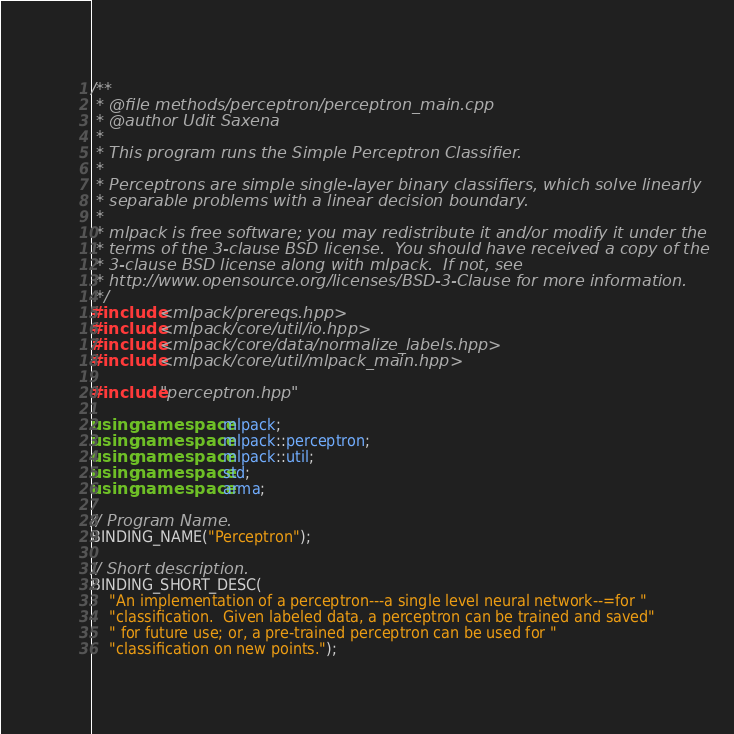Convert code to text. <code><loc_0><loc_0><loc_500><loc_500><_C++_>/**
 * @file methods/perceptron/perceptron_main.cpp
 * @author Udit Saxena
 *
 * This program runs the Simple Perceptron Classifier.
 *
 * Perceptrons are simple single-layer binary classifiers, which solve linearly
 * separable problems with a linear decision boundary.
 *
 * mlpack is free software; you may redistribute it and/or modify it under the
 * terms of the 3-clause BSD license.  You should have received a copy of the
 * 3-clause BSD license along with mlpack.  If not, see
 * http://www.opensource.org/licenses/BSD-3-Clause for more information.
 */
#include <mlpack/prereqs.hpp>
#include <mlpack/core/util/io.hpp>
#include <mlpack/core/data/normalize_labels.hpp>
#include <mlpack/core/util/mlpack_main.hpp>

#include "perceptron.hpp"

using namespace mlpack;
using namespace mlpack::perceptron;
using namespace mlpack::util;
using namespace std;
using namespace arma;

// Program Name.
BINDING_NAME("Perceptron");

// Short description.
BINDING_SHORT_DESC(
    "An implementation of a perceptron---a single level neural network--=for "
    "classification.  Given labeled data, a perceptron can be trained and saved"
    " for future use; or, a pre-trained perceptron can be used for "
    "classification on new points.");
</code> 